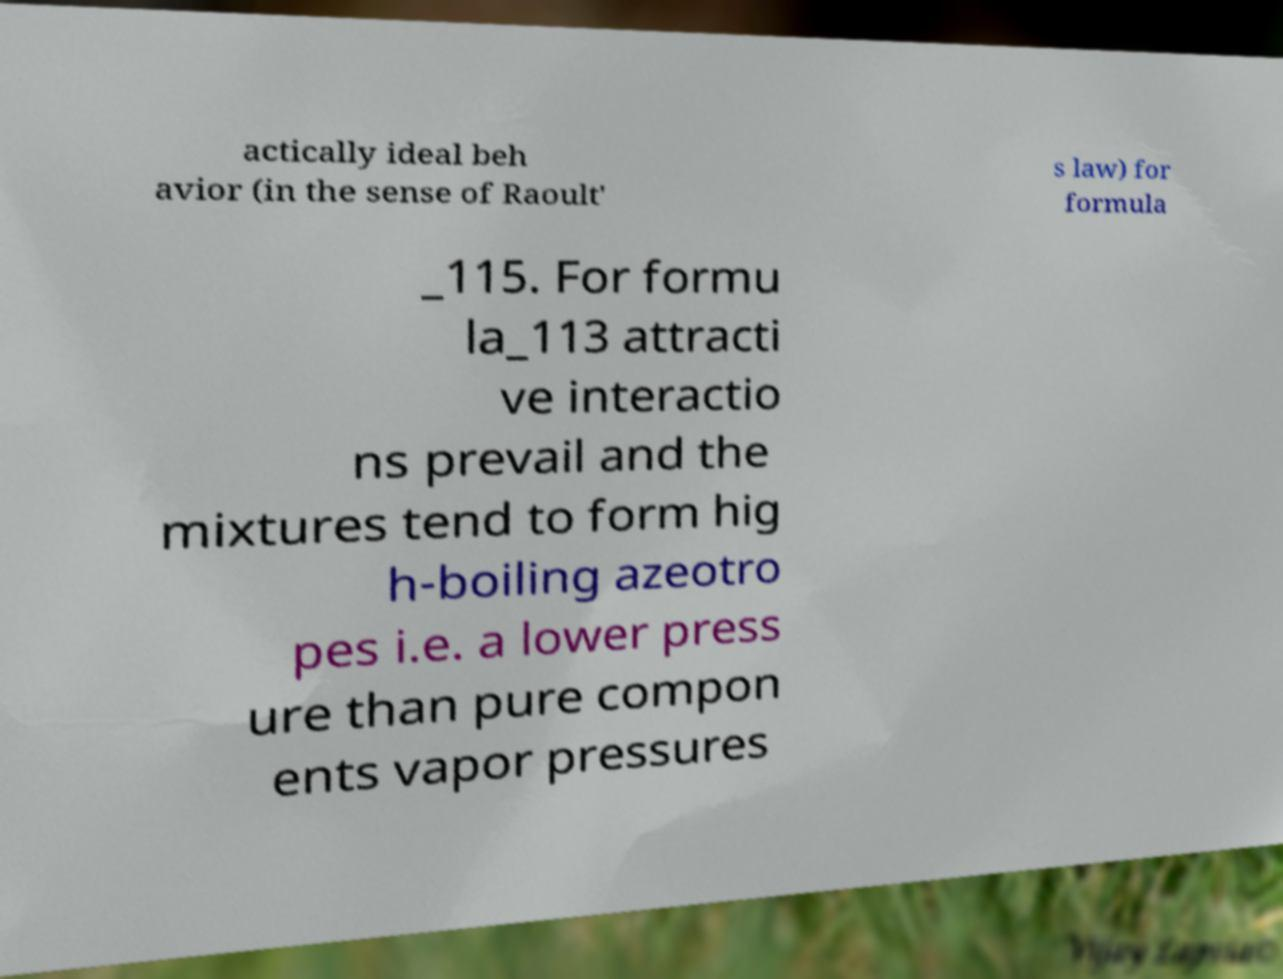What messages or text are displayed in this image? I need them in a readable, typed format. actically ideal beh avior (in the sense of Raoult' s law) for formula _115. For formu la_113 attracti ve interactio ns prevail and the mixtures tend to form hig h-boiling azeotro pes i.e. a lower press ure than pure compon ents vapor pressures 